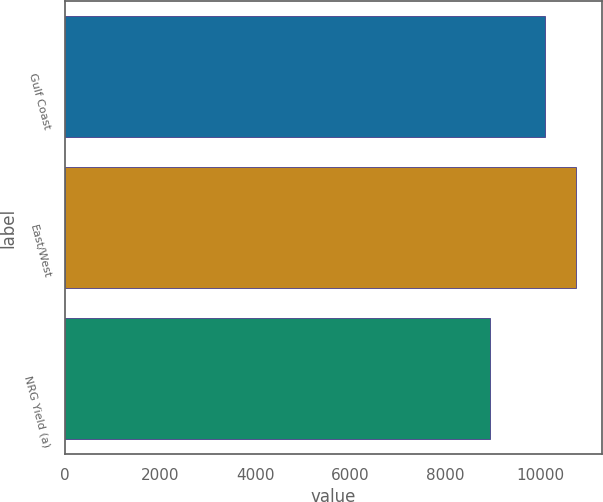Convert chart. <chart><loc_0><loc_0><loc_500><loc_500><bar_chart><fcel>Gulf Coast<fcel>East/West<fcel>NRG Yield (a)<nl><fcel>10106<fcel>10757<fcel>8938<nl></chart> 